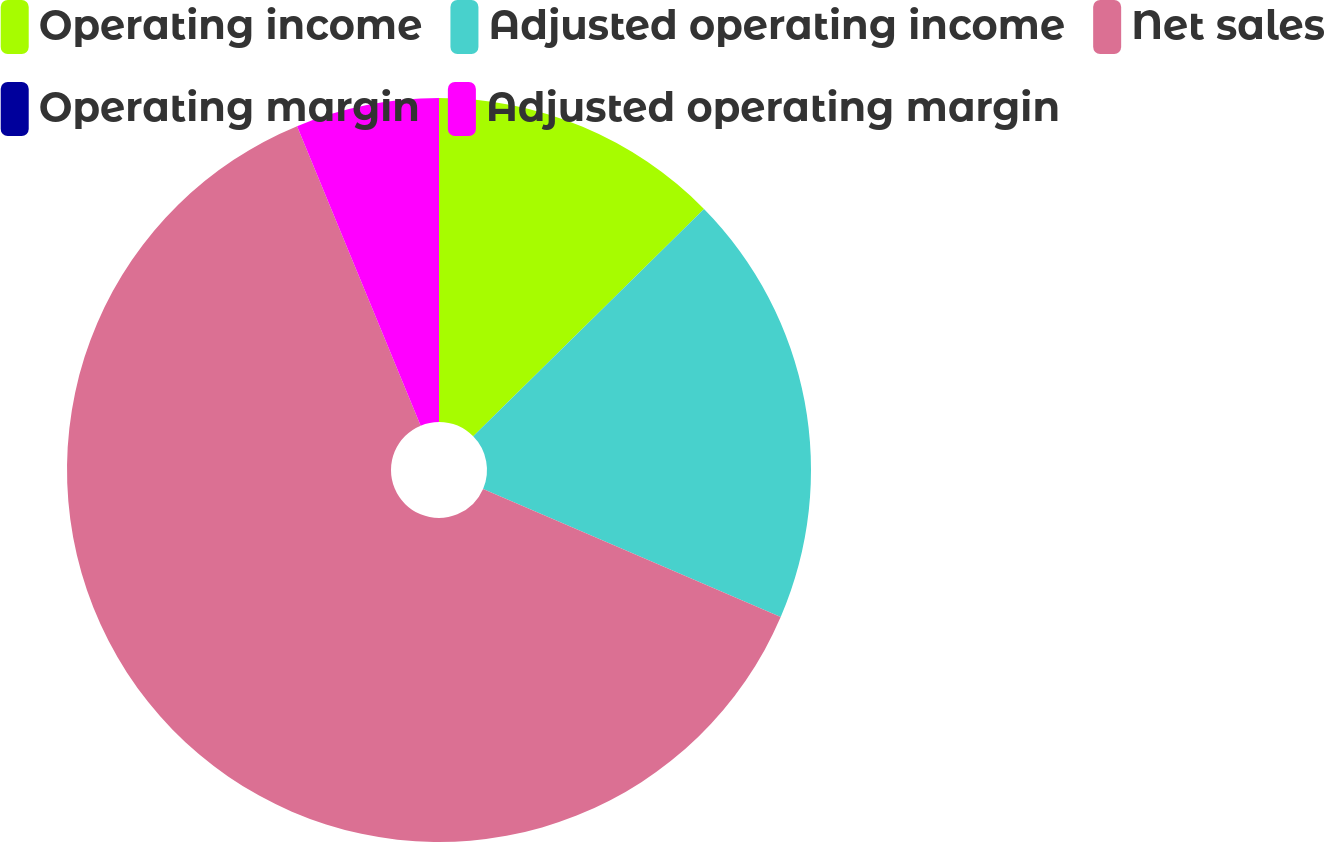Convert chart. <chart><loc_0><loc_0><loc_500><loc_500><pie_chart><fcel>Operating income<fcel>Adjusted operating income<fcel>Net sales<fcel>Operating margin<fcel>Adjusted operating margin<nl><fcel>12.62%<fcel>18.85%<fcel>62.3%<fcel>0.0%<fcel>6.23%<nl></chart> 